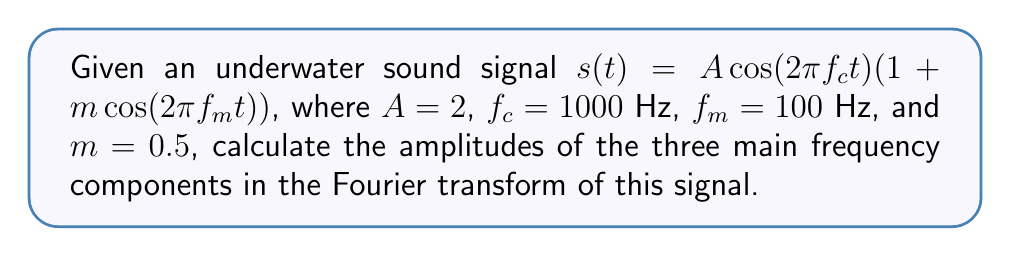Help me with this question. 1) The given signal is an amplitude-modulated (AM) signal with carrier frequency $f_c$ and modulating frequency $f_m$.

2) Expanding the signal:
   $$s(t) = A\cos(2\pi f_c t) + Am\cos(2\pi f_c t)\cos(2\pi f_m t)$$

3) Using the trigonometric identity $\cos A \cos B = \frac{1}{2}[\cos(A-B) + \cos(A+B)]$:
   $$s(t) = A\cos(2\pi f_c t) + \frac{Am}{2}[\cos(2\pi(f_c-f_m)t) + \cos(2\pi(f_c+f_m)t)]$$

4) This shows that the signal consists of three frequency components:
   - Carrier frequency: $f_c = 1000$ Hz
   - Lower sideband: $f_c - f_m = 900$ Hz
   - Upper sideband: $f_c + f_m = 1100$ Hz

5) The amplitudes of these components are:
   - Carrier: $A = 2$
   - Lower sideband: $\frac{Am}{2} = \frac{2 \cdot 0.5}{2} = 0.5$
   - Upper sideband: $\frac{Am}{2} = 0.5$

Therefore, the three main frequency components in the Fourier transform will have amplitudes 2, 0.5, and 0.5 at 1000 Hz, 900 Hz, and 1100 Hz respectively.
Answer: 2, 0.5, 0.5 